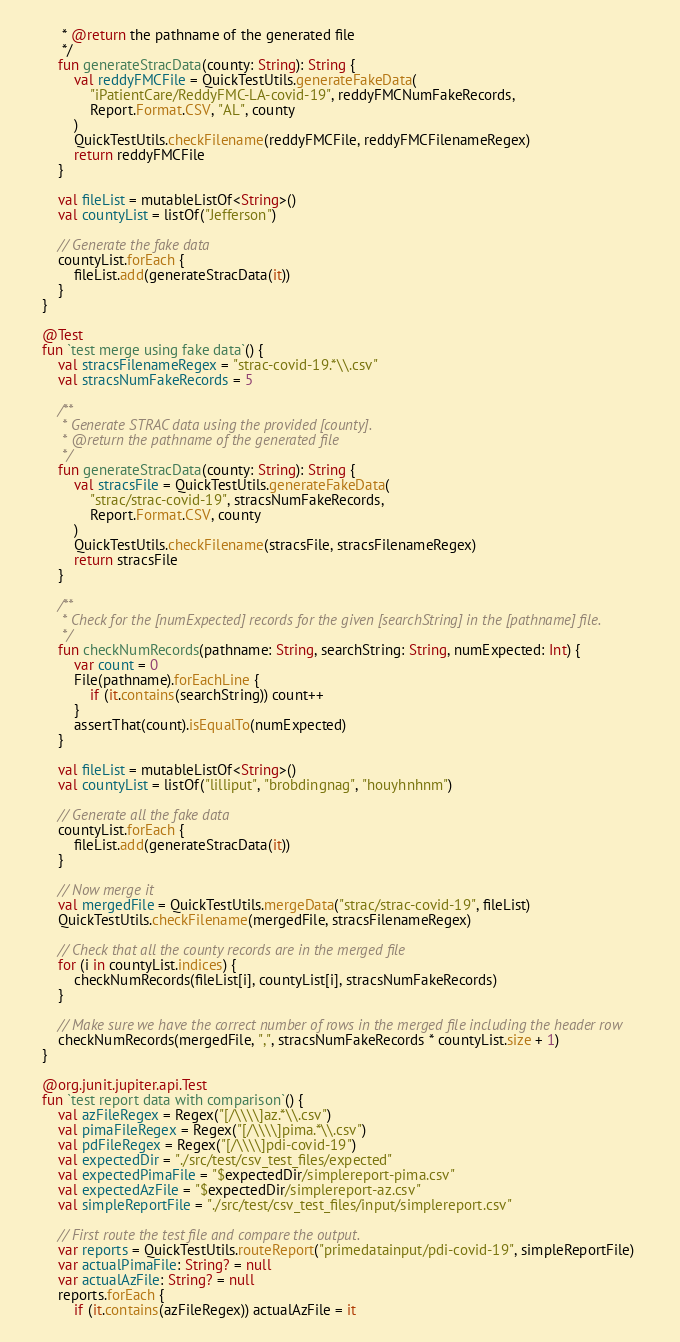Convert code to text. <code><loc_0><loc_0><loc_500><loc_500><_Kotlin_>         * @return the pathname of the generated file
         */
        fun generateStracData(county: String): String {
            val reddyFMCFile = QuickTestUtils.generateFakeData(
                "iPatientCare/ReddyFMC-LA-covid-19", reddyFMCNumFakeRecords,
                Report.Format.CSV, "AL", county
            )
            QuickTestUtils.checkFilename(reddyFMCFile, reddyFMCFilenameRegex)
            return reddyFMCFile
        }

        val fileList = mutableListOf<String>()
        val countyList = listOf("Jefferson")

        // Generate the fake data
        countyList.forEach {
            fileList.add(generateStracData(it))
        }
    }

    @Test
    fun `test merge using fake data`() {
        val stracsFilenameRegex = "strac-covid-19.*\\.csv"
        val stracsNumFakeRecords = 5

        /**
         * Generate STRAC data using the provided [county].
         * @return the pathname of the generated file
         */
        fun generateStracData(county: String): String {
            val stracsFile = QuickTestUtils.generateFakeData(
                "strac/strac-covid-19", stracsNumFakeRecords,
                Report.Format.CSV, county
            )
            QuickTestUtils.checkFilename(stracsFile, stracsFilenameRegex)
            return stracsFile
        }

        /**
         * Check for the [numExpected] records for the given [searchString] in the [pathname] file.
         */
        fun checkNumRecords(pathname: String, searchString: String, numExpected: Int) {
            var count = 0
            File(pathname).forEachLine {
                if (it.contains(searchString)) count++
            }
            assertThat(count).isEqualTo(numExpected)
        }

        val fileList = mutableListOf<String>()
        val countyList = listOf("lilliput", "brobdingnag", "houyhnhnm")

        // Generate all the fake data 
        countyList.forEach {
            fileList.add(generateStracData(it))
        }

        // Now merge it
        val mergedFile = QuickTestUtils.mergeData("strac/strac-covid-19", fileList)
        QuickTestUtils.checkFilename(mergedFile, stracsFilenameRegex)

        // Check that all the county records are in the merged file
        for (i in countyList.indices) {
            checkNumRecords(fileList[i], countyList[i], stracsNumFakeRecords)
        }

        // Make sure we have the correct number of rows in the merged file including the header row
        checkNumRecords(mergedFile, ",", stracsNumFakeRecords * countyList.size + 1)
    }

    @org.junit.jupiter.api.Test
    fun `test report data with comparison`() {
        val azFileRegex = Regex("[/\\\\]az.*\\.csv")
        val pimaFileRegex = Regex("[/\\\\]pima.*\\.csv")
        val pdFileRegex = Regex("[/\\\\]pdi-covid-19")
        val expectedDir = "./src/test/csv_test_files/expected"
        val expectedPimaFile = "$expectedDir/simplereport-pima.csv"
        val expectedAzFile = "$expectedDir/simplereport-az.csv"
        val simpleReportFile = "./src/test/csv_test_files/input/simplereport.csv"

        // First route the test file and compare the output.
        var reports = QuickTestUtils.routeReport("primedatainput/pdi-covid-19", simpleReportFile)
        var actualPimaFile: String? = null
        var actualAzFile: String? = null
        reports.forEach {
            if (it.contains(azFileRegex)) actualAzFile = it</code> 